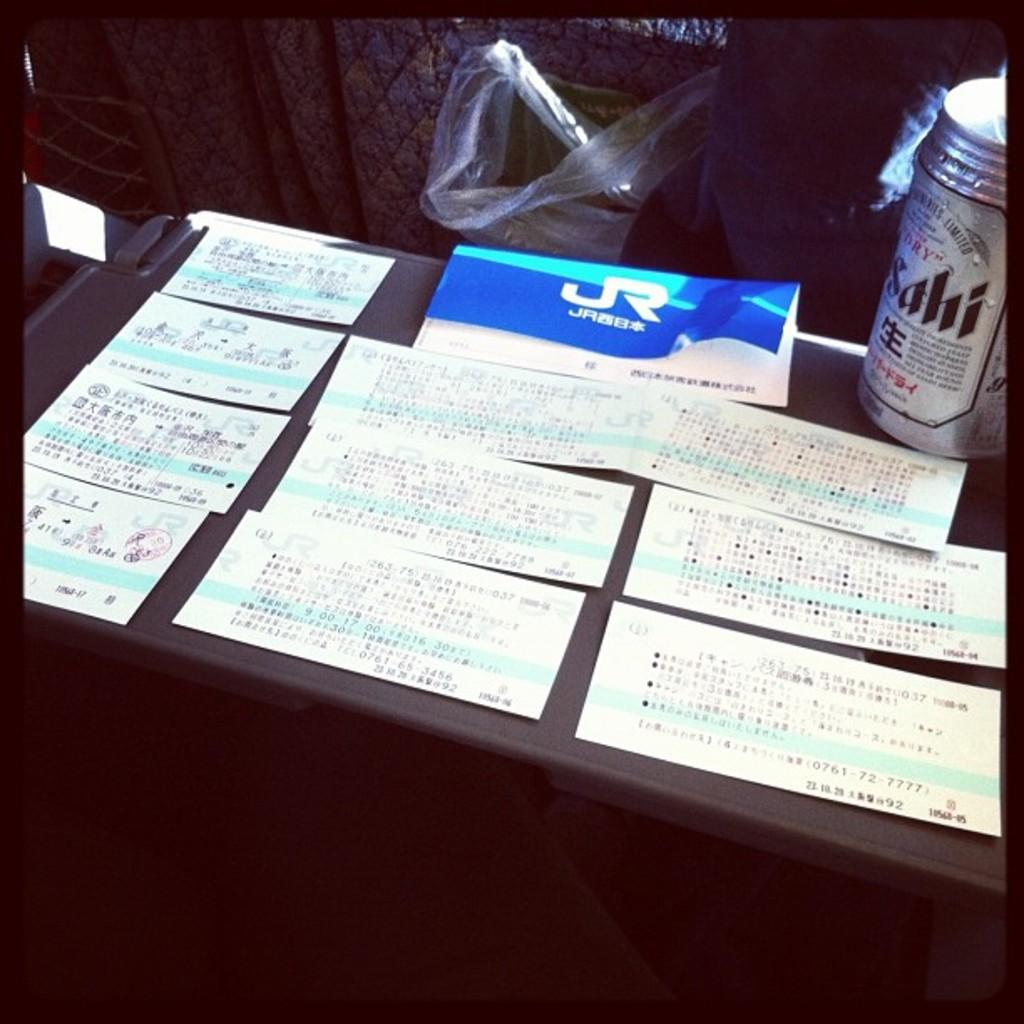Provide a one-sentence caption for the provided image. A table has lots of tickets and a can of Sahi beer. 